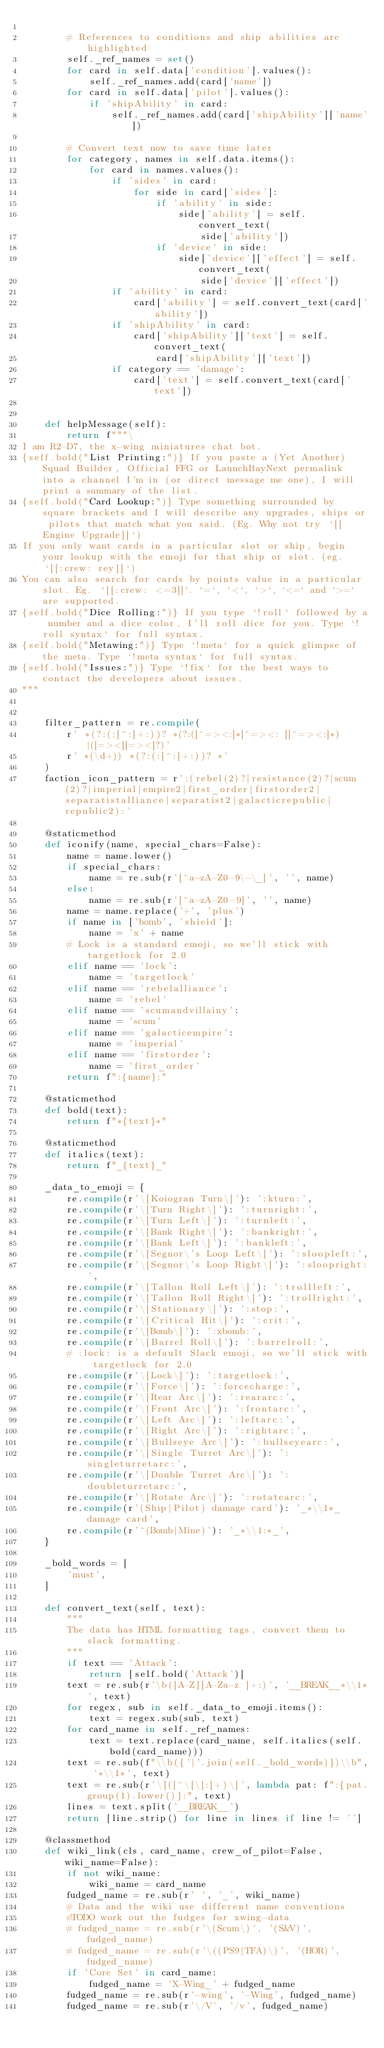Convert code to text. <code><loc_0><loc_0><loc_500><loc_500><_Python_>
        # References to conditions and ship abilities are highlighted
        self._ref_names = set()
        for card in self.data['condition'].values():
            self._ref_names.add(card['name'])
        for card in self.data['pilot'].values():
            if 'shipAbility' in card:
                self._ref_names.add(card['shipAbility']['name'])

        # Convert text now to save time later
        for category, names in self.data.items():
            for card in names.values():
                if 'sides' in card:
                    for side in card['sides']:
                        if 'ability' in side:
                            side['ability'] = self.convert_text(
                                side['ability'])
                        if 'device' in side:
                            side['device']['effect'] = self.convert_text(
                                side['device']['effect'])
                if 'ability' in card:
                    card['ability'] = self.convert_text(card['ability'])
                if 'shipAbility' in card:
                    card['shipAbility']['text'] = self.convert_text(
                        card['shipAbility']['text'])
                if category == 'damage':
                    card['text'] = self.convert_text(card['text'])


    def helpMessage(self):
        return f"""\
I am R2-D7, the x-wing miniatures chat bot.
{self.bold("List Printing:")} If you paste a (Yet Another) Squad Builder, Official FFG or LaunchBayNext permalink into a channel I'm in (or direct message me one), I will print a summary of the list.
{self.bold("Card Lookup:")} Type something surrounded by square brackets and I will describe any upgrades, ships or pilots that match what you said. (Eg. Why not try `[[Engine Upgrade]]`)
If you only want cards in a particular slot or ship, begin your lookup with the emoji for that ship or slot. (eg. `[[:crew: rey]]`)
You can also search for cards by points value in a particular slot. Eg. `[[:crew: <=3]]`. `=`, `<`, `>`, `<=` and `>=` are supported.
{self.bold("Dice Rolling:")} If you type `!roll` followed by a number and a dice color, I'll roll dice for you. Type `!roll syntax` for full syntax.
{self.bold("Metawing:")} Type `!meta` for a quick glimpse of the meta. Type `!meta syntax` for full syntax.
{self.bold("Issues:")} Type `!fix` for the best ways to contact the developers about issues.
"""


    filter_pattern = re.compile(
        r' *(?:(:[^:]+:))? *(?:([^=><:]*[^=><: ][^=><:]*)|([=><][=><]?)'
        r' *(\d+)) *(?:(:[^:]+:))? *'
    )
    faction_icon_pattern = r':(rebel(2)?|resistance(2)?|scum(2)?|imperial|empire2|first_order|firstorder2|separatistalliance|separatist2|galacticrepublic|republic2):'

    @staticmethod
    def iconify(name, special_chars=False):
        name = name.lower()
        if special_chars:
            name = re.sub(r'[^a-zA-Z0-9\-\_]', '', name)
        else:
            name = re.sub(r'[^a-zA-Z0-9]', '', name)
        name = name.replace('+', 'plus')
        if name in ['bomb', 'shield']:
            name = 'x' + name
        # Lock is a standard emoji, so we'll stick with targetlock for 2.0
        elif name == 'lock':
            name = 'targetlock'
        elif name == 'rebelalliance':
            name = 'rebel'
        elif name == 'scumandvillainy':
            name = 'scum'
        elif name == 'galacticempire':
            name = 'imperial'
        elif name == 'firstorder':
            name = 'first_order'
        return f":{name}:"

    @staticmethod
    def bold(text):
        return f"*{text}*"

    @staticmethod
    def italics(text):
        return f"_{text}_"

    _data_to_emoji = {
        re.compile(r'\[Koiogran Turn\]'): ':kturn:',
        re.compile(r'\[Turn Right\]'): ':turnright:',
        re.compile(r'\[Turn Left\]'): ':turnleft:',
        re.compile(r'\[Bank Right\]'): ':bankright:',
        re.compile(r'\[Bank Left\]'): ':bankleft:',
        re.compile(r'\[Segnor\'s Loop Left\]'): ':sloopleft:',
        re.compile(r'\[Segnor\'s Loop Right\]'): ':sloopright:',
        re.compile(r'\[Tallon Roll Left\]'): ':trollleft:',
        re.compile(r'\[Tallon Roll Right\]'): ':trollright:',
        re.compile(r'\[Stationary\]'): ':stop:',
        re.compile(r'\[Critical Hit\]'): ':crit:',
        re.compile(r'\[Bomb\]'): ':xbomb:',
        re.compile(r'\[Barrel Roll\]'): ':barrelroll:',
        # :lock: is a default Slack emoji, so we'll stick with targetlock for 2.0
        re.compile(r'\[Lock\]'): ':targetlock:',
        re.compile(r'\[Force\]'): ':forcecharge:',
        re.compile(r'\[Rear Arc\]'): ':reararc:',
        re.compile(r'\[Front Arc\]'): ':frontarc:',
        re.compile(r'\[Left Arc\]'): ':leftarc:',
        re.compile(r'\[Right Arc\]'): ':rightarc:',
        re.compile(r'\[Bullseye Arc\]'): ':bullseyearc:',
        re.compile(r'\[Single Turret Arc\]'): ':singleturretarc:',
        re.compile(r'\[Double Turret Arc\]'): ':doubleturretarc:',
        re.compile(r'\[Rotate Arc\]'): ':rotatearc:',
        re.compile(r'(Ship|Pilot) damage card'): '_*\\1*_ damage card',
        re.compile(r'^(Bomb|Mine)'): '_*\\1:*_',
    }

    _bold_words = [
        'must',
    ]

    def convert_text(self, text):
        """
        The data has HTML formatting tags, convert them to slack formatting.
        """
        if text == 'Attack':
            return [self.bold('Attack')]
        text = re.sub(r'\b([A-Z][A-Za-z ]+:)', '__BREAK__*\\1*', text)
        for regex, sub in self._data_to_emoji.items():
            text = regex.sub(sub, text)
        for card_name in self._ref_names:
            text = text.replace(card_name, self.italics(self.bold(card_name)))
        text = re.sub(f"\\b({'|'.join(self._bold_words)})\\b", '*\\1*', text)
        text = re.sub(r'\[([^\[\]:]+)\]', lambda pat: f":{pat.group(1).lower()}:", text)
        lines = text.split('__BREAK__')
        return [line.strip() for line in lines if line != '']

    @classmethod
    def wiki_link(cls, card_name, crew_of_pilot=False, wiki_name=False):
        if not wiki_name:
            wiki_name = card_name
        fudged_name = re.sub(r' ', '_', wiki_name)
        # Data and the wiki use different name conventions
        #TODO work out the fudges for xwing-data
        # fudged_name = re.sub(r'\(Scum\)', '(S&V)', fudged_name)
        # fudged_name = re.sub(r'\((PS9|TFA)\)', '(HOR)', fudged_name)
        if 'Core Set' in card_name:
            fudged_name = 'X-Wing_' + fudged_name
        fudged_name = re.sub(r'-wing', '-Wing', fudged_name)
        fudged_name = re.sub(r'\/V', '/v', fudged_name)</code> 